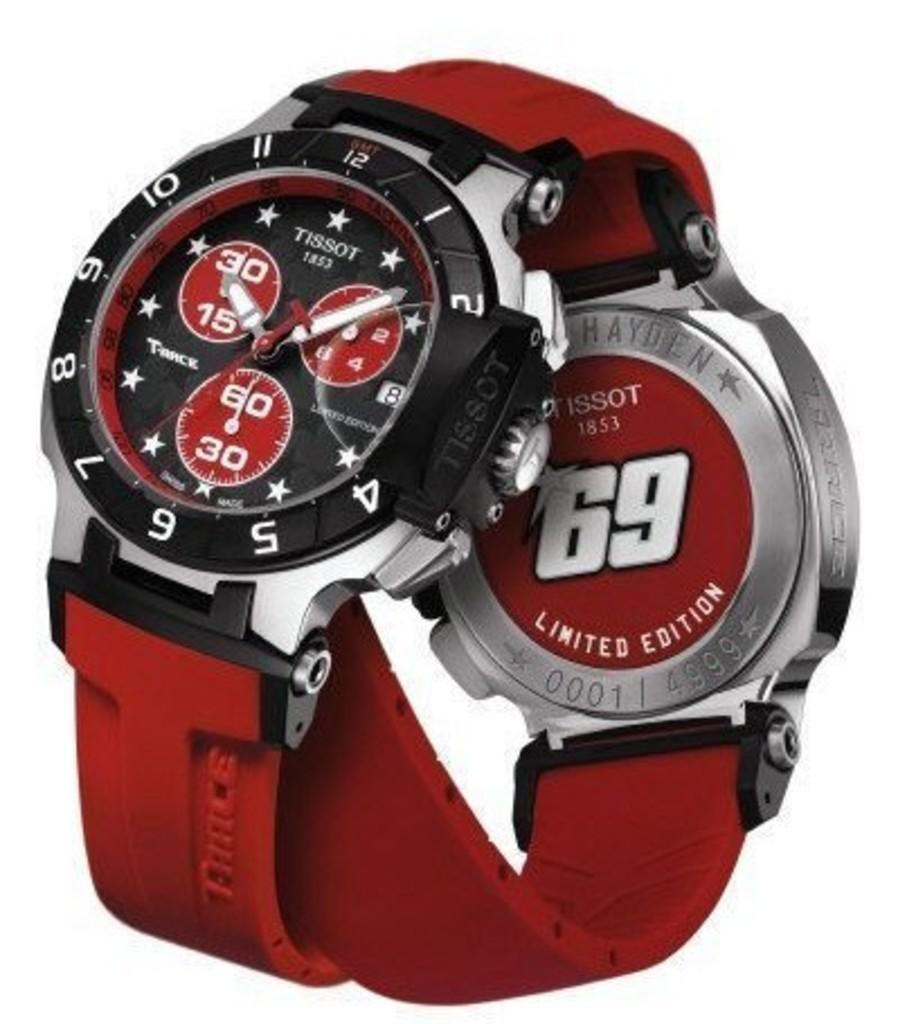<image>
Give a short and clear explanation of the subsequent image. A limited edition Tassot watch with red, black and silver trim. 